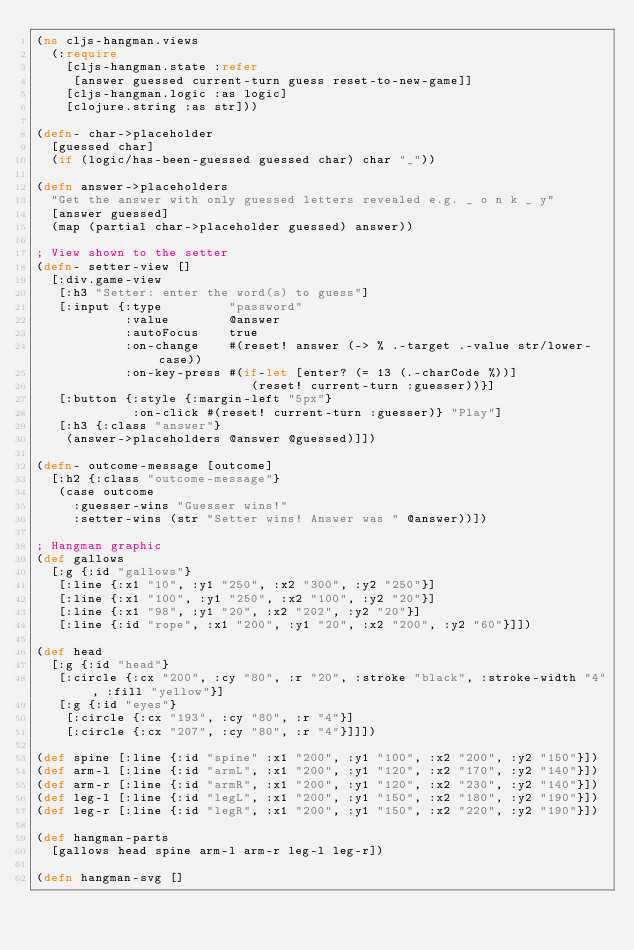<code> <loc_0><loc_0><loc_500><loc_500><_Clojure_>(ns cljs-hangman.views
  (:require
    [cljs-hangman.state :refer
     [answer guessed current-turn guess reset-to-new-game]]
    [cljs-hangman.logic :as logic]
    [clojure.string :as str]))

(defn- char->placeholder
  [guessed char]
  (if (logic/has-been-guessed guessed char) char "_"))

(defn answer->placeholders
  "Get the answer with only guessed letters revealed e.g. _ o n k _ y"
  [answer guessed]
  (map (partial char->placeholder guessed) answer))

; View shown to the setter
(defn- setter-view []
  [:div.game-view
   [:h3 "Setter: enter the word(s) to guess"]
   [:input {:type         "password"
            :value        @answer
            :autoFocus    true
            :on-change    #(reset! answer (-> % .-target .-value str/lower-case))
            :on-key-press #(if-let [enter? (= 13 (.-charCode %))]
                             (reset! current-turn :guesser))}]
   [:button {:style {:margin-left "5px"}
             :on-click #(reset! current-turn :guesser)} "Play"]
   [:h3 {:class "answer"}
    (answer->placeholders @answer @guessed)]])

(defn- outcome-message [outcome]
  [:h2 {:class "outcome-message"}
   (case outcome
     :guesser-wins "Guesser wins!"
     :setter-wins (str "Setter wins! Answer was " @answer))])

; Hangman graphic
(def gallows
  [:g {:id "gallows"}
   [:line {:x1 "10", :y1 "250", :x2 "300", :y2 "250"}]
   [:line {:x1 "100", :y1 "250", :x2 "100", :y2 "20"}]
   [:line {:x1 "98", :y1 "20", :x2 "202", :y2 "20"}]
   [:line {:id "rope", :x1 "200", :y1 "20", :x2 "200", :y2 "60"}]])

(def head
  [:g {:id "head"}
   [:circle {:cx "200", :cy "80", :r "20", :stroke "black", :stroke-width "4", :fill "yellow"}]
   [:g {:id "eyes"}
    [:circle {:cx "193", :cy "80", :r "4"}]
    [:circle {:cx "207", :cy "80", :r "4"}]]])

(def spine [:line {:id "spine" :x1 "200", :y1 "100", :x2 "200", :y2 "150"}])
(def arm-l [:line {:id "armL", :x1 "200", :y1 "120", :x2 "170", :y2 "140"}])
(def arm-r [:line {:id "armR", :x1 "200", :y1 "120", :x2 "230", :y2 "140"}])
(def leg-l [:line {:id "legL", :x1 "200", :y1 "150", :x2 "180", :y2 "190"}])
(def leg-r [:line {:id "legR", :x1 "200", :y1 "150", :x2 "220", :y2 "190"}])

(def hangman-parts
  [gallows head spine arm-l arm-r leg-l leg-r])

(defn hangman-svg []</code> 